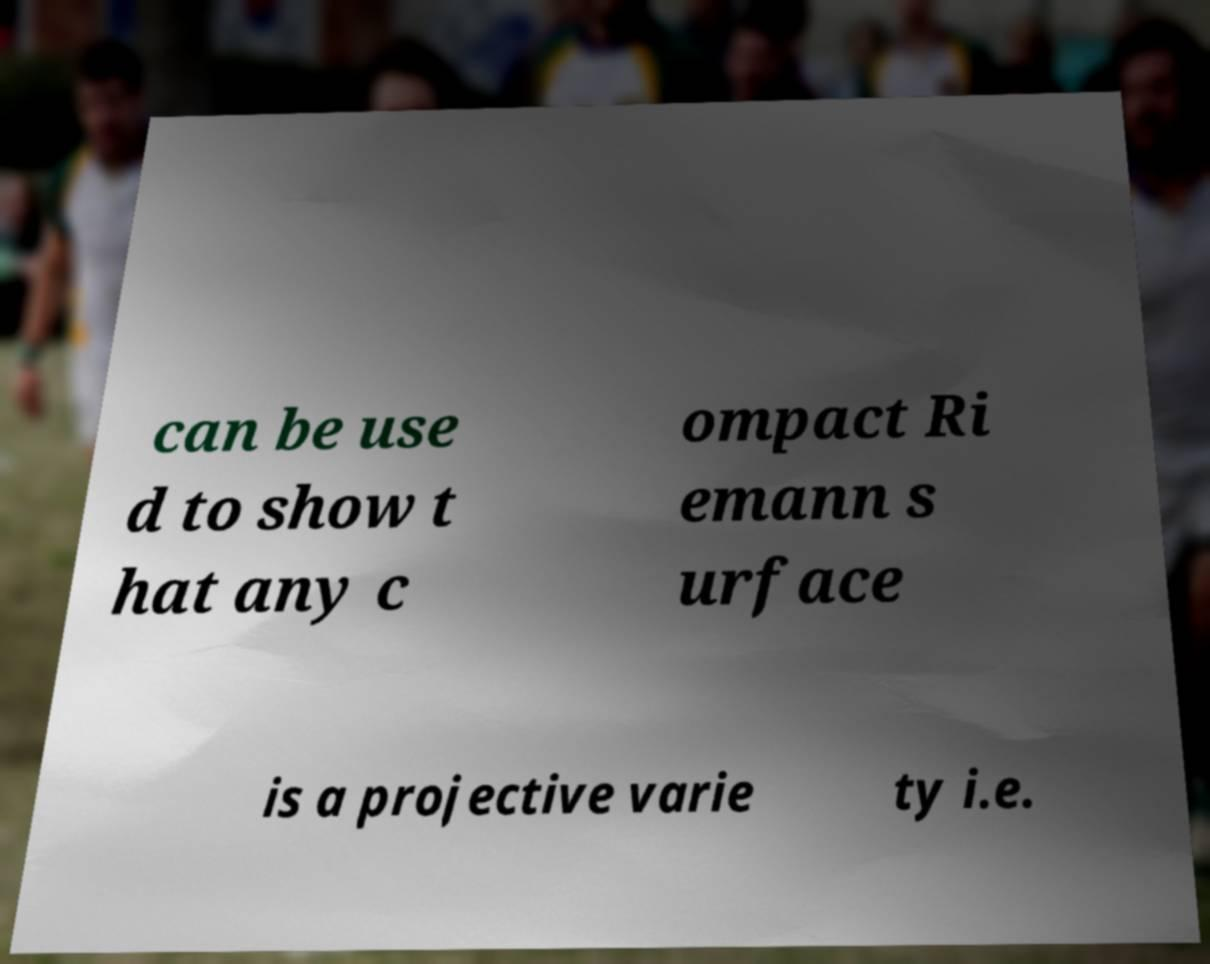There's text embedded in this image that I need extracted. Can you transcribe it verbatim? can be use d to show t hat any c ompact Ri emann s urface is a projective varie ty i.e. 